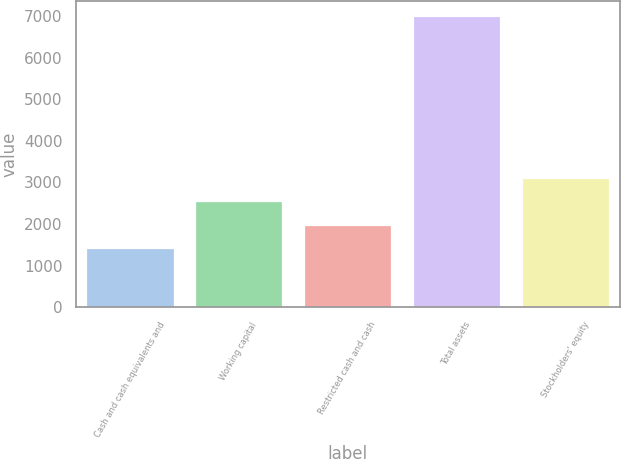Convert chart. <chart><loc_0><loc_0><loc_500><loc_500><bar_chart><fcel>Cash and cash equivalents and<fcel>Working capital<fcel>Restricted cash and cash<fcel>Total assets<fcel>Stockholders' equity<nl><fcel>1429<fcel>2544.6<fcel>1986.8<fcel>7007<fcel>3102.4<nl></chart> 